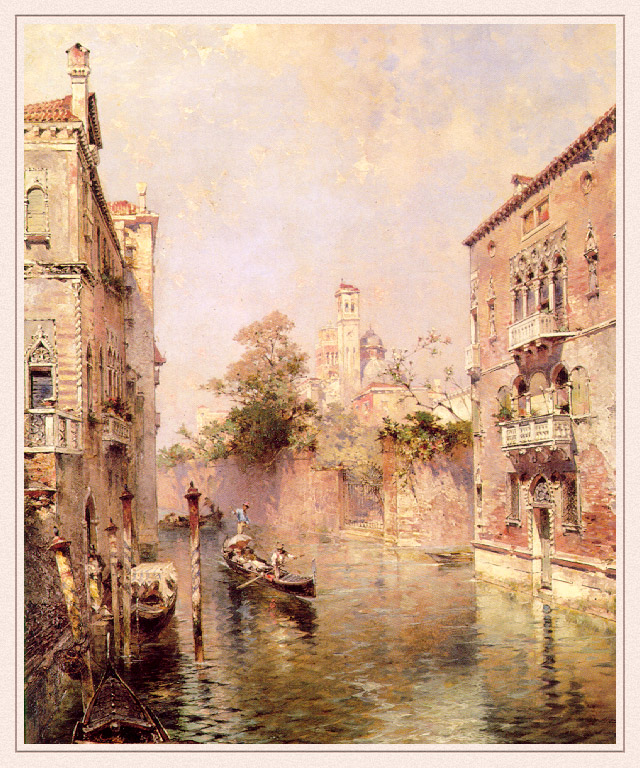What might be happening just out of frame in this image? Just out of frame, one can imagine the bustling life typical of Venetian canals. Perhaps a small market is set up along the canal's edge, with vendors selling fresh produce and crafts. In another direction, a group of musicians might be performing, filling the air with soothing melodies that blend seamlessly with the sounds of the gently lapping water. Around a corner, perhaps a quiet café is alive with chatter, where locals and tourists alike partake in rich conversations over cups of espresso. Can you describe an interaction that might be happening among people in this scene? In this serene Venetian canal scene, imagine a gondolier guiding the gondola through the waterways, engaging in lively conversation with his passengers. Perhaps they are visitors, enthralled by the intricate details of the surrounding architecture, as the gondolier passionately shares tales of Venice's storied past. Meanwhile, on a nearby balcony, residents exchange warm greetings and laughter, embodying the close-knit community spirit. The serene environment not only serves as a picturesque backdrop but also fosters an atmosphere of camaraderie and cultural exchange. 